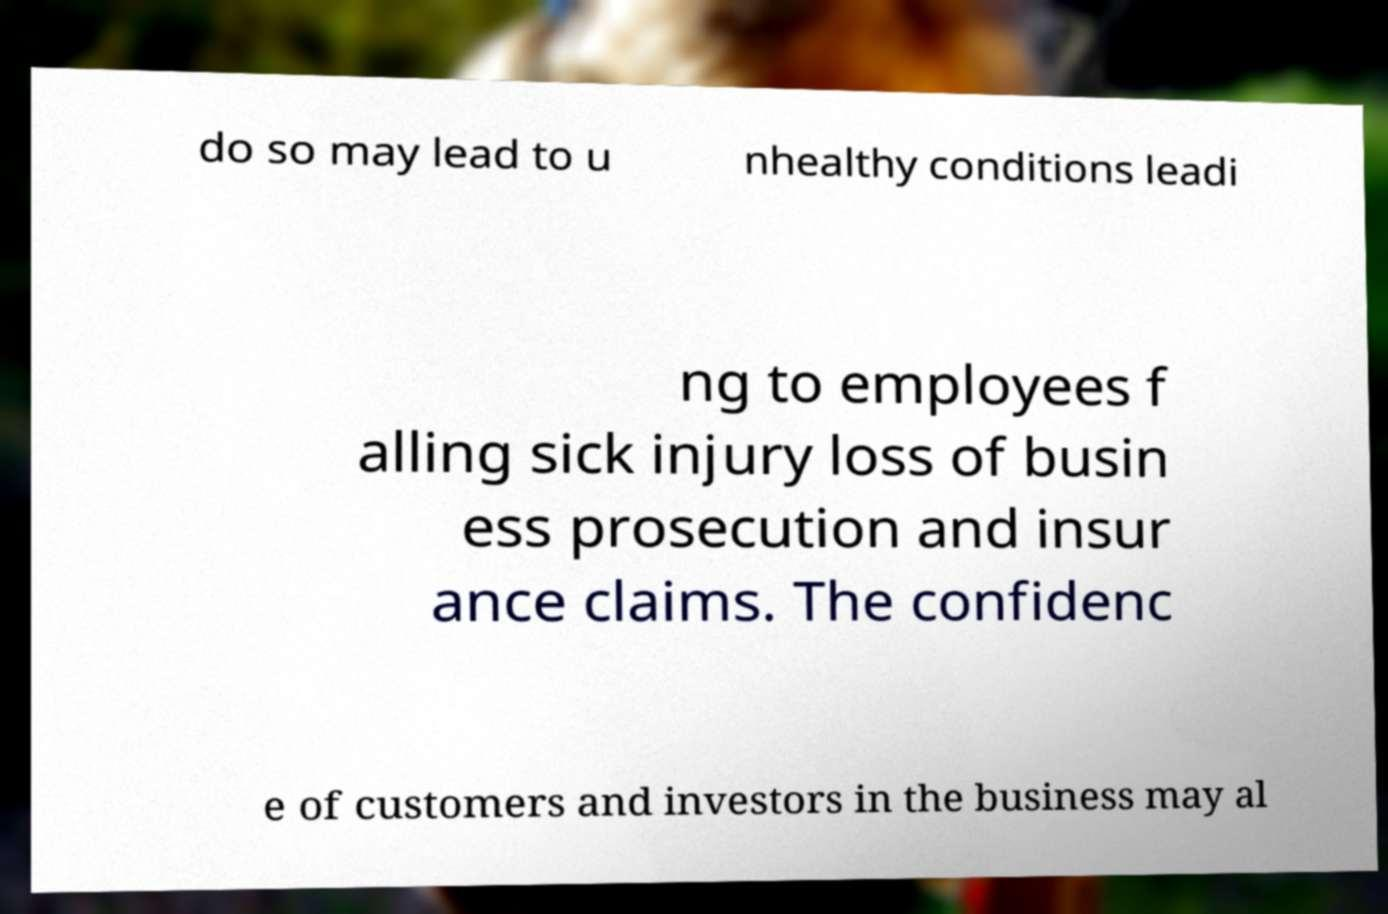There's text embedded in this image that I need extracted. Can you transcribe it verbatim? do so may lead to u nhealthy conditions leadi ng to employees f alling sick injury loss of busin ess prosecution and insur ance claims. The confidenc e of customers and investors in the business may al 